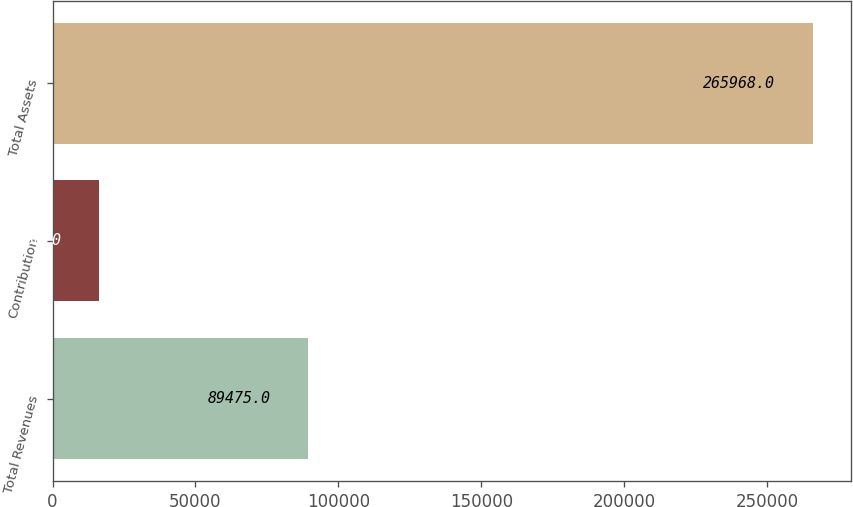<chart> <loc_0><loc_0><loc_500><loc_500><bar_chart><fcel>Total Revenues<fcel>Contribution<fcel>Total Assets<nl><fcel>89475<fcel>16250<fcel>265968<nl></chart> 